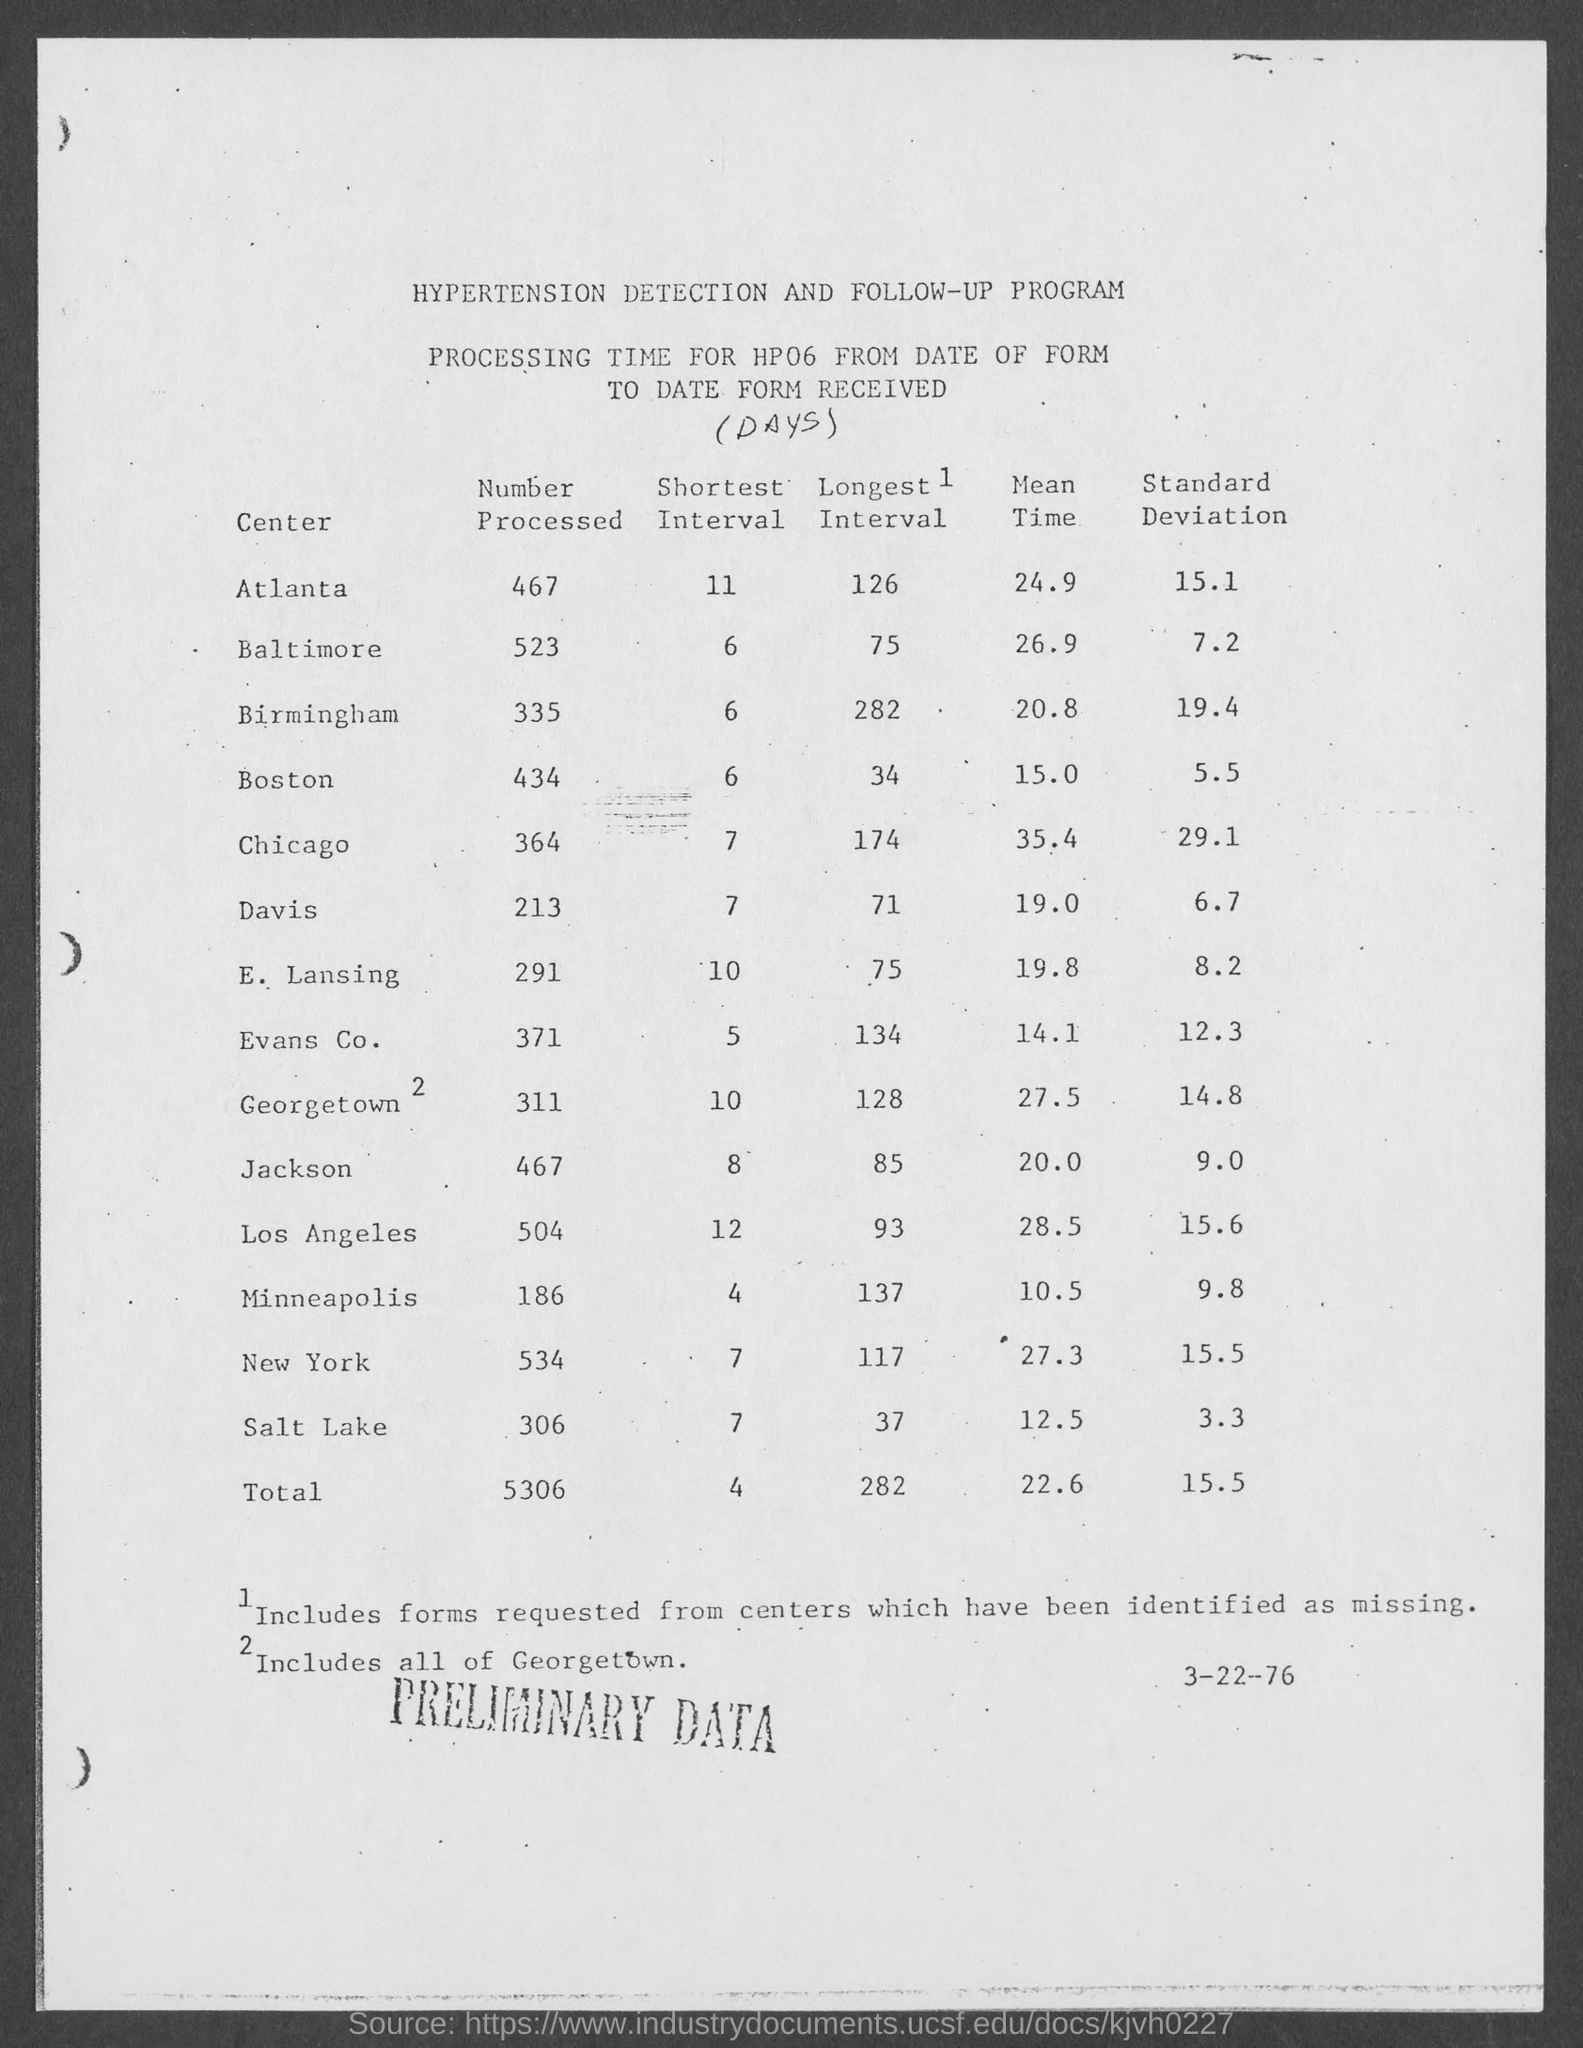How much is the standard deviation of Atlanta center?
Your response must be concise. 15.1. 